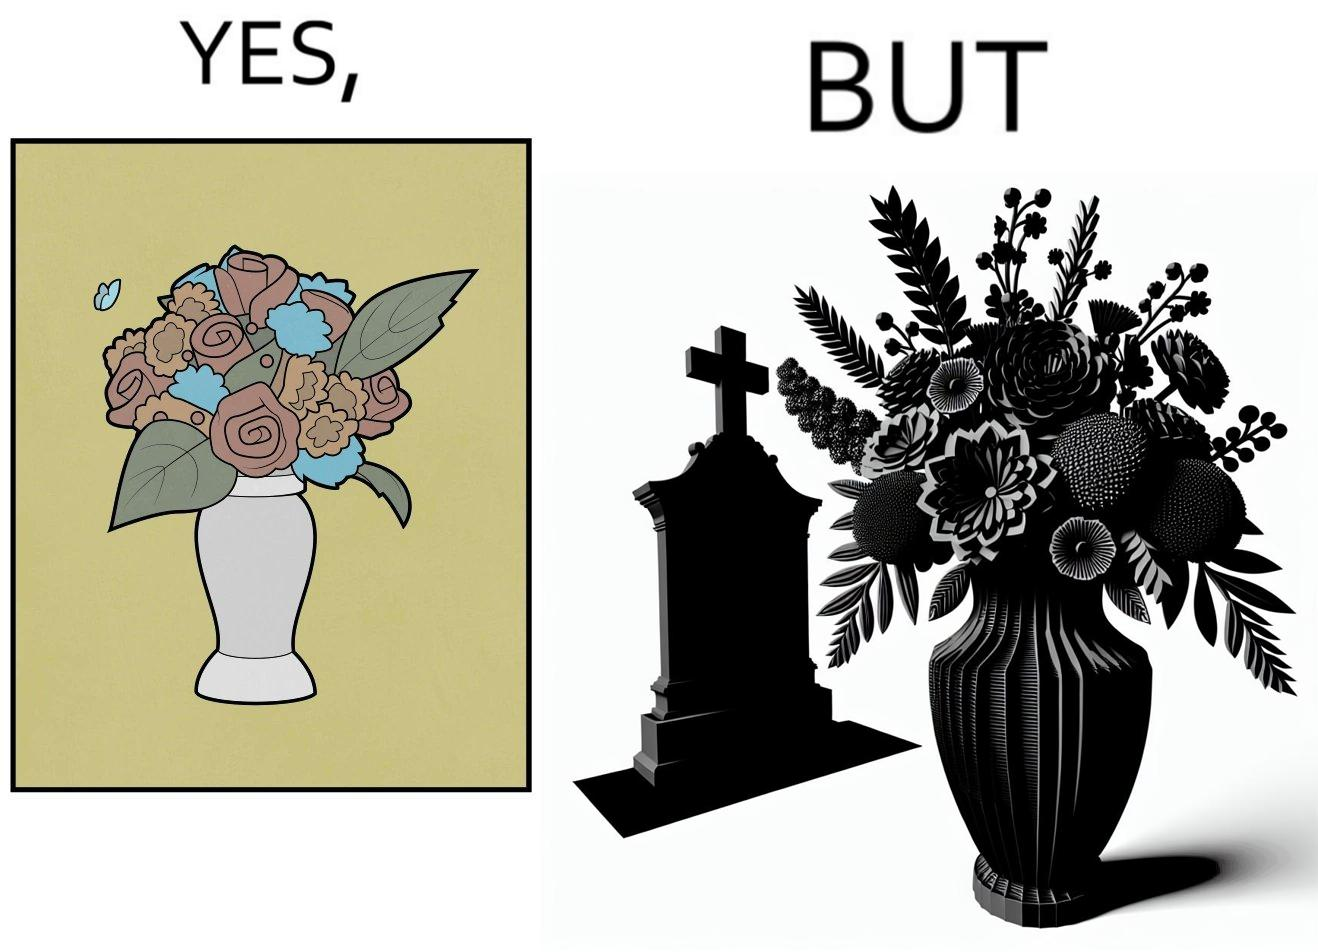Explain why this image is satirical. The image is ironic, because in the first image a vase full of different beautiful flowers is seen which spreads a feeling of positivity, cheerfulness etc., whereas in the second image when the same vase is put in front of a grave stone it produces a feeling of sorrow 